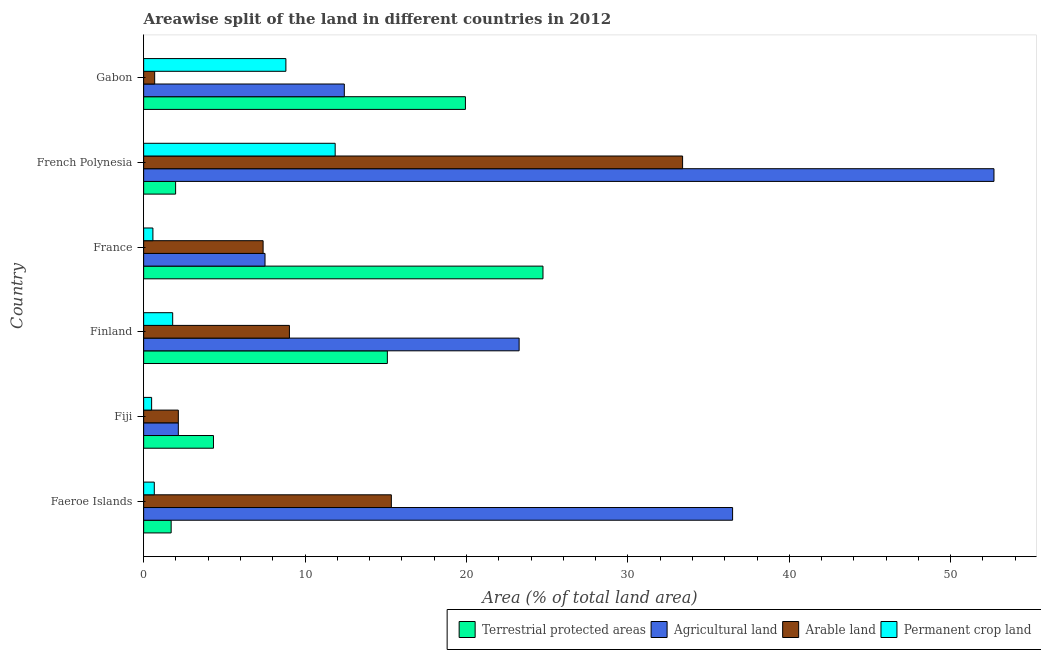Are the number of bars per tick equal to the number of legend labels?
Your response must be concise. Yes. Are the number of bars on each tick of the Y-axis equal?
Provide a short and direct response. Yes. How many bars are there on the 6th tick from the top?
Your response must be concise. 4. How many bars are there on the 6th tick from the bottom?
Make the answer very short. 4. What is the label of the 1st group of bars from the top?
Offer a terse response. Gabon. What is the percentage of area under arable land in Faeroe Islands?
Your answer should be very brief. 15.35. Across all countries, what is the maximum percentage of area under arable land?
Your response must be concise. 33.39. Across all countries, what is the minimum percentage of area under agricultural land?
Your response must be concise. 2.15. In which country was the percentage of area under permanent crop land maximum?
Your answer should be compact. French Polynesia. In which country was the percentage of area under arable land minimum?
Provide a short and direct response. Gabon. What is the total percentage of area under arable land in the graph?
Your answer should be very brief. 68. What is the difference between the percentage of area under agricultural land in French Polynesia and that in Gabon?
Make the answer very short. 40.25. What is the difference between the percentage of area under permanent crop land in Finland and the percentage of area under agricultural land in French Polynesia?
Ensure brevity in your answer.  -50.88. What is the average percentage of area under permanent crop land per country?
Offer a very short reply. 4.03. What is the difference between the percentage of area under agricultural land and percentage of area under permanent crop land in Faeroe Islands?
Provide a short and direct response. 35.83. What is the ratio of the percentage of land under terrestrial protection in Fiji to that in France?
Keep it short and to the point. 0.17. Is the difference between the percentage of area under arable land in Faeroe Islands and Finland greater than the difference between the percentage of land under terrestrial protection in Faeroe Islands and Finland?
Your response must be concise. Yes. What is the difference between the highest and the second highest percentage of area under agricultural land?
Provide a short and direct response. 16.19. What is the difference between the highest and the lowest percentage of area under agricultural land?
Your answer should be compact. 50.53. Is it the case that in every country, the sum of the percentage of area under agricultural land and percentage of area under permanent crop land is greater than the sum of percentage of land under terrestrial protection and percentage of area under arable land?
Offer a very short reply. No. What does the 2nd bar from the top in Finland represents?
Give a very brief answer. Arable land. What does the 3rd bar from the bottom in French Polynesia represents?
Your response must be concise. Arable land. Is it the case that in every country, the sum of the percentage of land under terrestrial protection and percentage of area under agricultural land is greater than the percentage of area under arable land?
Ensure brevity in your answer.  Yes. How many bars are there?
Offer a very short reply. 24. How many countries are there in the graph?
Your answer should be compact. 6. Are the values on the major ticks of X-axis written in scientific E-notation?
Your response must be concise. No. Does the graph contain any zero values?
Your response must be concise. No. Does the graph contain grids?
Keep it short and to the point. No. Where does the legend appear in the graph?
Your answer should be very brief. Bottom right. How many legend labels are there?
Ensure brevity in your answer.  4. How are the legend labels stacked?
Your response must be concise. Horizontal. What is the title of the graph?
Your answer should be very brief. Areawise split of the land in different countries in 2012. Does "Secondary" appear as one of the legend labels in the graph?
Your answer should be very brief. No. What is the label or title of the X-axis?
Make the answer very short. Area (% of total land area). What is the Area (% of total land area) of Terrestrial protected areas in Faeroe Islands?
Your answer should be compact. 1.7. What is the Area (% of total land area) in Agricultural land in Faeroe Islands?
Provide a short and direct response. 36.49. What is the Area (% of total land area) of Arable land in Faeroe Islands?
Keep it short and to the point. 15.35. What is the Area (% of total land area) in Permanent crop land in Faeroe Islands?
Offer a very short reply. 0.66. What is the Area (% of total land area) of Terrestrial protected areas in Fiji?
Your response must be concise. 4.33. What is the Area (% of total land area) in Agricultural land in Fiji?
Offer a terse response. 2.15. What is the Area (% of total land area) of Arable land in Fiji?
Offer a very short reply. 2.15. What is the Area (% of total land area) in Permanent crop land in Fiji?
Your answer should be compact. 0.49. What is the Area (% of total land area) of Terrestrial protected areas in Finland?
Make the answer very short. 15.1. What is the Area (% of total land area) of Agricultural land in Finland?
Your response must be concise. 23.26. What is the Area (% of total land area) of Arable land in Finland?
Provide a succinct answer. 9.03. What is the Area (% of total land area) of Permanent crop land in Finland?
Offer a terse response. 1.8. What is the Area (% of total land area) of Terrestrial protected areas in France?
Offer a very short reply. 24.74. What is the Area (% of total land area) of Agricultural land in France?
Provide a short and direct response. 7.52. What is the Area (% of total land area) in Arable land in France?
Your answer should be very brief. 7.4. What is the Area (% of total land area) of Permanent crop land in France?
Offer a terse response. 0.57. What is the Area (% of total land area) of Terrestrial protected areas in French Polynesia?
Your answer should be very brief. 1.98. What is the Area (% of total land area) in Agricultural land in French Polynesia?
Provide a short and direct response. 52.68. What is the Area (% of total land area) in Arable land in French Polynesia?
Offer a very short reply. 33.39. What is the Area (% of total land area) in Permanent crop land in French Polynesia?
Offer a terse response. 11.87. What is the Area (% of total land area) of Terrestrial protected areas in Gabon?
Offer a very short reply. 19.94. What is the Area (% of total land area) in Agricultural land in Gabon?
Ensure brevity in your answer.  12.43. What is the Area (% of total land area) of Arable land in Gabon?
Your response must be concise. 0.68. What is the Area (% of total land area) in Permanent crop land in Gabon?
Your answer should be compact. 8.81. Across all countries, what is the maximum Area (% of total land area) of Terrestrial protected areas?
Ensure brevity in your answer.  24.74. Across all countries, what is the maximum Area (% of total land area) in Agricultural land?
Provide a short and direct response. 52.68. Across all countries, what is the maximum Area (% of total land area) in Arable land?
Your answer should be compact. 33.39. Across all countries, what is the maximum Area (% of total land area) in Permanent crop land?
Your response must be concise. 11.87. Across all countries, what is the minimum Area (% of total land area) in Terrestrial protected areas?
Offer a very short reply. 1.7. Across all countries, what is the minimum Area (% of total land area) of Agricultural land?
Offer a terse response. 2.15. Across all countries, what is the minimum Area (% of total land area) in Arable land?
Provide a succinct answer. 0.68. Across all countries, what is the minimum Area (% of total land area) of Permanent crop land?
Ensure brevity in your answer.  0.49. What is the total Area (% of total land area) of Terrestrial protected areas in the graph?
Keep it short and to the point. 67.79. What is the total Area (% of total land area) of Agricultural land in the graph?
Your answer should be compact. 134.53. What is the total Area (% of total land area) of Arable land in the graph?
Your answer should be compact. 68. What is the total Area (% of total land area) in Permanent crop land in the graph?
Provide a succinct answer. 24.21. What is the difference between the Area (% of total land area) of Terrestrial protected areas in Faeroe Islands and that in Fiji?
Your answer should be compact. -2.62. What is the difference between the Area (% of total land area) of Agricultural land in Faeroe Islands and that in Fiji?
Your response must be concise. 34.34. What is the difference between the Area (% of total land area) of Arable land in Faeroe Islands and that in Fiji?
Offer a very short reply. 13.2. What is the difference between the Area (% of total land area) of Permanent crop land in Faeroe Islands and that in Fiji?
Make the answer very short. 0.17. What is the difference between the Area (% of total land area) of Terrestrial protected areas in Faeroe Islands and that in Finland?
Make the answer very short. -13.39. What is the difference between the Area (% of total land area) in Agricultural land in Faeroe Islands and that in Finland?
Your answer should be very brief. 13.23. What is the difference between the Area (% of total land area) of Arable land in Faeroe Islands and that in Finland?
Make the answer very short. 6.31. What is the difference between the Area (% of total land area) in Permanent crop land in Faeroe Islands and that in Finland?
Your answer should be very brief. -1.14. What is the difference between the Area (% of total land area) in Terrestrial protected areas in Faeroe Islands and that in France?
Keep it short and to the point. -23.04. What is the difference between the Area (% of total land area) of Agricultural land in Faeroe Islands and that in France?
Offer a terse response. 28.97. What is the difference between the Area (% of total land area) of Arable land in Faeroe Islands and that in France?
Keep it short and to the point. 7.95. What is the difference between the Area (% of total land area) in Permanent crop land in Faeroe Islands and that in France?
Ensure brevity in your answer.  0.09. What is the difference between the Area (% of total land area) of Terrestrial protected areas in Faeroe Islands and that in French Polynesia?
Offer a very short reply. -0.28. What is the difference between the Area (% of total land area) of Agricultural land in Faeroe Islands and that in French Polynesia?
Give a very brief answer. -16.19. What is the difference between the Area (% of total land area) in Arable land in Faeroe Islands and that in French Polynesia?
Ensure brevity in your answer.  -18.04. What is the difference between the Area (% of total land area) in Permanent crop land in Faeroe Islands and that in French Polynesia?
Keep it short and to the point. -11.21. What is the difference between the Area (% of total land area) of Terrestrial protected areas in Faeroe Islands and that in Gabon?
Provide a short and direct response. -18.23. What is the difference between the Area (% of total land area) of Agricultural land in Faeroe Islands and that in Gabon?
Offer a terse response. 24.06. What is the difference between the Area (% of total land area) in Arable land in Faeroe Islands and that in Gabon?
Provide a short and direct response. 14.66. What is the difference between the Area (% of total land area) of Permanent crop land in Faeroe Islands and that in Gabon?
Give a very brief answer. -8.15. What is the difference between the Area (% of total land area) of Terrestrial protected areas in Fiji and that in Finland?
Offer a terse response. -10.77. What is the difference between the Area (% of total land area) of Agricultural land in Fiji and that in Finland?
Offer a very short reply. -21.11. What is the difference between the Area (% of total land area) in Arable land in Fiji and that in Finland?
Provide a short and direct response. -6.88. What is the difference between the Area (% of total land area) of Permanent crop land in Fiji and that in Finland?
Provide a succinct answer. -1.3. What is the difference between the Area (% of total land area) of Terrestrial protected areas in Fiji and that in France?
Your answer should be compact. -20.41. What is the difference between the Area (% of total land area) of Agricultural land in Fiji and that in France?
Provide a short and direct response. -5.37. What is the difference between the Area (% of total land area) of Arable land in Fiji and that in France?
Keep it short and to the point. -5.25. What is the difference between the Area (% of total land area) in Permanent crop land in Fiji and that in France?
Provide a short and direct response. -0.08. What is the difference between the Area (% of total land area) of Terrestrial protected areas in Fiji and that in French Polynesia?
Give a very brief answer. 2.35. What is the difference between the Area (% of total land area) of Agricultural land in Fiji and that in French Polynesia?
Your answer should be very brief. -50.53. What is the difference between the Area (% of total land area) of Arable land in Fiji and that in French Polynesia?
Your answer should be very brief. -31.24. What is the difference between the Area (% of total land area) of Permanent crop land in Fiji and that in French Polynesia?
Your answer should be compact. -11.37. What is the difference between the Area (% of total land area) of Terrestrial protected areas in Fiji and that in Gabon?
Provide a short and direct response. -15.61. What is the difference between the Area (% of total land area) in Agricultural land in Fiji and that in Gabon?
Your answer should be compact. -10.28. What is the difference between the Area (% of total land area) in Arable land in Fiji and that in Gabon?
Offer a very short reply. 1.47. What is the difference between the Area (% of total land area) in Permanent crop land in Fiji and that in Gabon?
Give a very brief answer. -8.32. What is the difference between the Area (% of total land area) of Terrestrial protected areas in Finland and that in France?
Offer a very short reply. -9.64. What is the difference between the Area (% of total land area) of Agricultural land in Finland and that in France?
Keep it short and to the point. 15.74. What is the difference between the Area (% of total land area) of Arable land in Finland and that in France?
Your answer should be compact. 1.63. What is the difference between the Area (% of total land area) of Permanent crop land in Finland and that in France?
Make the answer very short. 1.23. What is the difference between the Area (% of total land area) of Terrestrial protected areas in Finland and that in French Polynesia?
Make the answer very short. 13.12. What is the difference between the Area (% of total land area) in Agricultural land in Finland and that in French Polynesia?
Your response must be concise. -29.42. What is the difference between the Area (% of total land area) of Arable land in Finland and that in French Polynesia?
Make the answer very short. -24.36. What is the difference between the Area (% of total land area) in Permanent crop land in Finland and that in French Polynesia?
Provide a succinct answer. -10.07. What is the difference between the Area (% of total land area) of Terrestrial protected areas in Finland and that in Gabon?
Give a very brief answer. -4.84. What is the difference between the Area (% of total land area) in Agricultural land in Finland and that in Gabon?
Your response must be concise. 10.83. What is the difference between the Area (% of total land area) of Arable land in Finland and that in Gabon?
Offer a very short reply. 8.35. What is the difference between the Area (% of total land area) in Permanent crop land in Finland and that in Gabon?
Ensure brevity in your answer.  -7.01. What is the difference between the Area (% of total land area) in Terrestrial protected areas in France and that in French Polynesia?
Offer a very short reply. 22.76. What is the difference between the Area (% of total land area) in Agricultural land in France and that in French Polynesia?
Keep it short and to the point. -45.16. What is the difference between the Area (% of total land area) of Arable land in France and that in French Polynesia?
Offer a terse response. -25.99. What is the difference between the Area (% of total land area) of Permanent crop land in France and that in French Polynesia?
Provide a short and direct response. -11.29. What is the difference between the Area (% of total land area) of Terrestrial protected areas in France and that in Gabon?
Your response must be concise. 4.81. What is the difference between the Area (% of total land area) of Agricultural land in France and that in Gabon?
Provide a succinct answer. -4.91. What is the difference between the Area (% of total land area) in Arable land in France and that in Gabon?
Your response must be concise. 6.72. What is the difference between the Area (% of total land area) of Permanent crop land in France and that in Gabon?
Make the answer very short. -8.24. What is the difference between the Area (% of total land area) of Terrestrial protected areas in French Polynesia and that in Gabon?
Your response must be concise. -17.96. What is the difference between the Area (% of total land area) in Agricultural land in French Polynesia and that in Gabon?
Offer a very short reply. 40.25. What is the difference between the Area (% of total land area) in Arable land in French Polynesia and that in Gabon?
Ensure brevity in your answer.  32.71. What is the difference between the Area (% of total land area) in Permanent crop land in French Polynesia and that in Gabon?
Ensure brevity in your answer.  3.05. What is the difference between the Area (% of total land area) in Terrestrial protected areas in Faeroe Islands and the Area (% of total land area) in Agricultural land in Fiji?
Ensure brevity in your answer.  -0.44. What is the difference between the Area (% of total land area) in Terrestrial protected areas in Faeroe Islands and the Area (% of total land area) in Arable land in Fiji?
Offer a very short reply. -0.44. What is the difference between the Area (% of total land area) of Terrestrial protected areas in Faeroe Islands and the Area (% of total land area) of Permanent crop land in Fiji?
Ensure brevity in your answer.  1.21. What is the difference between the Area (% of total land area) in Agricultural land in Faeroe Islands and the Area (% of total land area) in Arable land in Fiji?
Ensure brevity in your answer.  34.34. What is the difference between the Area (% of total land area) of Agricultural land in Faeroe Islands and the Area (% of total land area) of Permanent crop land in Fiji?
Your response must be concise. 35.99. What is the difference between the Area (% of total land area) in Arable land in Faeroe Islands and the Area (% of total land area) in Permanent crop land in Fiji?
Your answer should be very brief. 14.85. What is the difference between the Area (% of total land area) of Terrestrial protected areas in Faeroe Islands and the Area (% of total land area) of Agricultural land in Finland?
Provide a short and direct response. -21.56. What is the difference between the Area (% of total land area) of Terrestrial protected areas in Faeroe Islands and the Area (% of total land area) of Arable land in Finland?
Provide a short and direct response. -7.33. What is the difference between the Area (% of total land area) in Terrestrial protected areas in Faeroe Islands and the Area (% of total land area) in Permanent crop land in Finland?
Your answer should be compact. -0.09. What is the difference between the Area (% of total land area) in Agricultural land in Faeroe Islands and the Area (% of total land area) in Arable land in Finland?
Your answer should be very brief. 27.46. What is the difference between the Area (% of total land area) in Agricultural land in Faeroe Islands and the Area (% of total land area) in Permanent crop land in Finland?
Your answer should be compact. 34.69. What is the difference between the Area (% of total land area) in Arable land in Faeroe Islands and the Area (% of total land area) in Permanent crop land in Finland?
Provide a short and direct response. 13.55. What is the difference between the Area (% of total land area) in Terrestrial protected areas in Faeroe Islands and the Area (% of total land area) in Agricultural land in France?
Make the answer very short. -5.82. What is the difference between the Area (% of total land area) of Terrestrial protected areas in Faeroe Islands and the Area (% of total land area) of Arable land in France?
Offer a very short reply. -5.7. What is the difference between the Area (% of total land area) in Terrestrial protected areas in Faeroe Islands and the Area (% of total land area) in Permanent crop land in France?
Your answer should be compact. 1.13. What is the difference between the Area (% of total land area) of Agricultural land in Faeroe Islands and the Area (% of total land area) of Arable land in France?
Provide a succinct answer. 29.09. What is the difference between the Area (% of total land area) in Agricultural land in Faeroe Islands and the Area (% of total land area) in Permanent crop land in France?
Ensure brevity in your answer.  35.91. What is the difference between the Area (% of total land area) in Arable land in Faeroe Islands and the Area (% of total land area) in Permanent crop land in France?
Your answer should be compact. 14.77. What is the difference between the Area (% of total land area) in Terrestrial protected areas in Faeroe Islands and the Area (% of total land area) in Agricultural land in French Polynesia?
Your response must be concise. -50.98. What is the difference between the Area (% of total land area) of Terrestrial protected areas in Faeroe Islands and the Area (% of total land area) of Arable land in French Polynesia?
Offer a very short reply. -31.69. What is the difference between the Area (% of total land area) in Terrestrial protected areas in Faeroe Islands and the Area (% of total land area) in Permanent crop land in French Polynesia?
Ensure brevity in your answer.  -10.16. What is the difference between the Area (% of total land area) of Agricultural land in Faeroe Islands and the Area (% of total land area) of Arable land in French Polynesia?
Keep it short and to the point. 3.1. What is the difference between the Area (% of total land area) in Agricultural land in Faeroe Islands and the Area (% of total land area) in Permanent crop land in French Polynesia?
Your response must be concise. 24.62. What is the difference between the Area (% of total land area) in Arable land in Faeroe Islands and the Area (% of total land area) in Permanent crop land in French Polynesia?
Provide a succinct answer. 3.48. What is the difference between the Area (% of total land area) in Terrestrial protected areas in Faeroe Islands and the Area (% of total land area) in Agricultural land in Gabon?
Provide a short and direct response. -10.73. What is the difference between the Area (% of total land area) of Terrestrial protected areas in Faeroe Islands and the Area (% of total land area) of Arable land in Gabon?
Provide a short and direct response. 1.02. What is the difference between the Area (% of total land area) in Terrestrial protected areas in Faeroe Islands and the Area (% of total land area) in Permanent crop land in Gabon?
Give a very brief answer. -7.11. What is the difference between the Area (% of total land area) in Agricultural land in Faeroe Islands and the Area (% of total land area) in Arable land in Gabon?
Offer a very short reply. 35.8. What is the difference between the Area (% of total land area) of Agricultural land in Faeroe Islands and the Area (% of total land area) of Permanent crop land in Gabon?
Your answer should be compact. 27.68. What is the difference between the Area (% of total land area) of Arable land in Faeroe Islands and the Area (% of total land area) of Permanent crop land in Gabon?
Keep it short and to the point. 6.53. What is the difference between the Area (% of total land area) in Terrestrial protected areas in Fiji and the Area (% of total land area) in Agricultural land in Finland?
Provide a succinct answer. -18.94. What is the difference between the Area (% of total land area) in Terrestrial protected areas in Fiji and the Area (% of total land area) in Arable land in Finland?
Provide a succinct answer. -4.71. What is the difference between the Area (% of total land area) of Terrestrial protected areas in Fiji and the Area (% of total land area) of Permanent crop land in Finland?
Your answer should be compact. 2.53. What is the difference between the Area (% of total land area) in Agricultural land in Fiji and the Area (% of total land area) in Arable land in Finland?
Your response must be concise. -6.88. What is the difference between the Area (% of total land area) of Agricultural land in Fiji and the Area (% of total land area) of Permanent crop land in Finland?
Your response must be concise. 0.35. What is the difference between the Area (% of total land area) in Arable land in Fiji and the Area (% of total land area) in Permanent crop land in Finland?
Offer a very short reply. 0.35. What is the difference between the Area (% of total land area) of Terrestrial protected areas in Fiji and the Area (% of total land area) of Agricultural land in France?
Offer a terse response. -3.19. What is the difference between the Area (% of total land area) in Terrestrial protected areas in Fiji and the Area (% of total land area) in Arable land in France?
Provide a succinct answer. -3.08. What is the difference between the Area (% of total land area) in Terrestrial protected areas in Fiji and the Area (% of total land area) in Permanent crop land in France?
Offer a terse response. 3.75. What is the difference between the Area (% of total land area) of Agricultural land in Fiji and the Area (% of total land area) of Arable land in France?
Your answer should be very brief. -5.25. What is the difference between the Area (% of total land area) in Agricultural land in Fiji and the Area (% of total land area) in Permanent crop land in France?
Make the answer very short. 1.58. What is the difference between the Area (% of total land area) of Arable land in Fiji and the Area (% of total land area) of Permanent crop land in France?
Give a very brief answer. 1.58. What is the difference between the Area (% of total land area) of Terrestrial protected areas in Fiji and the Area (% of total land area) of Agricultural land in French Polynesia?
Make the answer very short. -48.36. What is the difference between the Area (% of total land area) of Terrestrial protected areas in Fiji and the Area (% of total land area) of Arable land in French Polynesia?
Your answer should be very brief. -29.06. What is the difference between the Area (% of total land area) in Terrestrial protected areas in Fiji and the Area (% of total land area) in Permanent crop land in French Polynesia?
Offer a very short reply. -7.54. What is the difference between the Area (% of total land area) of Agricultural land in Fiji and the Area (% of total land area) of Arable land in French Polynesia?
Provide a succinct answer. -31.24. What is the difference between the Area (% of total land area) in Agricultural land in Fiji and the Area (% of total land area) in Permanent crop land in French Polynesia?
Keep it short and to the point. -9.72. What is the difference between the Area (% of total land area) of Arable land in Fiji and the Area (% of total land area) of Permanent crop land in French Polynesia?
Your answer should be very brief. -9.72. What is the difference between the Area (% of total land area) of Terrestrial protected areas in Fiji and the Area (% of total land area) of Agricultural land in Gabon?
Your answer should be very brief. -8.11. What is the difference between the Area (% of total land area) of Terrestrial protected areas in Fiji and the Area (% of total land area) of Arable land in Gabon?
Offer a very short reply. 3.64. What is the difference between the Area (% of total land area) in Terrestrial protected areas in Fiji and the Area (% of total land area) in Permanent crop land in Gabon?
Make the answer very short. -4.49. What is the difference between the Area (% of total land area) of Agricultural land in Fiji and the Area (% of total land area) of Arable land in Gabon?
Your answer should be very brief. 1.47. What is the difference between the Area (% of total land area) in Agricultural land in Fiji and the Area (% of total land area) in Permanent crop land in Gabon?
Offer a terse response. -6.66. What is the difference between the Area (% of total land area) of Arable land in Fiji and the Area (% of total land area) of Permanent crop land in Gabon?
Ensure brevity in your answer.  -6.66. What is the difference between the Area (% of total land area) in Terrestrial protected areas in Finland and the Area (% of total land area) in Agricultural land in France?
Keep it short and to the point. 7.58. What is the difference between the Area (% of total land area) in Terrestrial protected areas in Finland and the Area (% of total land area) in Arable land in France?
Keep it short and to the point. 7.7. What is the difference between the Area (% of total land area) in Terrestrial protected areas in Finland and the Area (% of total land area) in Permanent crop land in France?
Provide a short and direct response. 14.53. What is the difference between the Area (% of total land area) in Agricultural land in Finland and the Area (% of total land area) in Arable land in France?
Offer a very short reply. 15.86. What is the difference between the Area (% of total land area) in Agricultural land in Finland and the Area (% of total land area) in Permanent crop land in France?
Offer a very short reply. 22.69. What is the difference between the Area (% of total land area) of Arable land in Finland and the Area (% of total land area) of Permanent crop land in France?
Provide a succinct answer. 8.46. What is the difference between the Area (% of total land area) in Terrestrial protected areas in Finland and the Area (% of total land area) in Agricultural land in French Polynesia?
Your response must be concise. -37.58. What is the difference between the Area (% of total land area) in Terrestrial protected areas in Finland and the Area (% of total land area) in Arable land in French Polynesia?
Your response must be concise. -18.29. What is the difference between the Area (% of total land area) of Terrestrial protected areas in Finland and the Area (% of total land area) of Permanent crop land in French Polynesia?
Your response must be concise. 3.23. What is the difference between the Area (% of total land area) in Agricultural land in Finland and the Area (% of total land area) in Arable land in French Polynesia?
Make the answer very short. -10.13. What is the difference between the Area (% of total land area) in Agricultural land in Finland and the Area (% of total land area) in Permanent crop land in French Polynesia?
Provide a short and direct response. 11.4. What is the difference between the Area (% of total land area) of Arable land in Finland and the Area (% of total land area) of Permanent crop land in French Polynesia?
Your answer should be compact. -2.83. What is the difference between the Area (% of total land area) in Terrestrial protected areas in Finland and the Area (% of total land area) in Agricultural land in Gabon?
Keep it short and to the point. 2.67. What is the difference between the Area (% of total land area) of Terrestrial protected areas in Finland and the Area (% of total land area) of Arable land in Gabon?
Your answer should be very brief. 14.42. What is the difference between the Area (% of total land area) of Terrestrial protected areas in Finland and the Area (% of total land area) of Permanent crop land in Gabon?
Provide a succinct answer. 6.29. What is the difference between the Area (% of total land area) in Agricultural land in Finland and the Area (% of total land area) in Arable land in Gabon?
Offer a very short reply. 22.58. What is the difference between the Area (% of total land area) in Agricultural land in Finland and the Area (% of total land area) in Permanent crop land in Gabon?
Your answer should be very brief. 14.45. What is the difference between the Area (% of total land area) of Arable land in Finland and the Area (% of total land area) of Permanent crop land in Gabon?
Give a very brief answer. 0.22. What is the difference between the Area (% of total land area) of Terrestrial protected areas in France and the Area (% of total land area) of Agricultural land in French Polynesia?
Keep it short and to the point. -27.94. What is the difference between the Area (% of total land area) of Terrestrial protected areas in France and the Area (% of total land area) of Arable land in French Polynesia?
Give a very brief answer. -8.65. What is the difference between the Area (% of total land area) of Terrestrial protected areas in France and the Area (% of total land area) of Permanent crop land in French Polynesia?
Keep it short and to the point. 12.87. What is the difference between the Area (% of total land area) in Agricultural land in France and the Area (% of total land area) in Arable land in French Polynesia?
Offer a terse response. -25.87. What is the difference between the Area (% of total land area) of Agricultural land in France and the Area (% of total land area) of Permanent crop land in French Polynesia?
Offer a terse response. -4.35. What is the difference between the Area (% of total land area) of Arable land in France and the Area (% of total land area) of Permanent crop land in French Polynesia?
Ensure brevity in your answer.  -4.46. What is the difference between the Area (% of total land area) of Terrestrial protected areas in France and the Area (% of total land area) of Agricultural land in Gabon?
Ensure brevity in your answer.  12.31. What is the difference between the Area (% of total land area) of Terrestrial protected areas in France and the Area (% of total land area) of Arable land in Gabon?
Provide a short and direct response. 24.06. What is the difference between the Area (% of total land area) in Terrestrial protected areas in France and the Area (% of total land area) in Permanent crop land in Gabon?
Your answer should be very brief. 15.93. What is the difference between the Area (% of total land area) of Agricultural land in France and the Area (% of total land area) of Arable land in Gabon?
Make the answer very short. 6.84. What is the difference between the Area (% of total land area) of Agricultural land in France and the Area (% of total land area) of Permanent crop land in Gabon?
Keep it short and to the point. -1.29. What is the difference between the Area (% of total land area) in Arable land in France and the Area (% of total land area) in Permanent crop land in Gabon?
Give a very brief answer. -1.41. What is the difference between the Area (% of total land area) in Terrestrial protected areas in French Polynesia and the Area (% of total land area) in Agricultural land in Gabon?
Provide a succinct answer. -10.45. What is the difference between the Area (% of total land area) in Terrestrial protected areas in French Polynesia and the Area (% of total land area) in Arable land in Gabon?
Provide a short and direct response. 1.3. What is the difference between the Area (% of total land area) in Terrestrial protected areas in French Polynesia and the Area (% of total land area) in Permanent crop land in Gabon?
Your answer should be compact. -6.83. What is the difference between the Area (% of total land area) of Agricultural land in French Polynesia and the Area (% of total land area) of Arable land in Gabon?
Keep it short and to the point. 52. What is the difference between the Area (% of total land area) in Agricultural land in French Polynesia and the Area (% of total land area) in Permanent crop land in Gabon?
Keep it short and to the point. 43.87. What is the difference between the Area (% of total land area) of Arable land in French Polynesia and the Area (% of total land area) of Permanent crop land in Gabon?
Offer a terse response. 24.58. What is the average Area (% of total land area) of Terrestrial protected areas per country?
Your answer should be compact. 11.3. What is the average Area (% of total land area) in Agricultural land per country?
Offer a terse response. 22.42. What is the average Area (% of total land area) of Arable land per country?
Your answer should be compact. 11.33. What is the average Area (% of total land area) in Permanent crop land per country?
Ensure brevity in your answer.  4.03. What is the difference between the Area (% of total land area) of Terrestrial protected areas and Area (% of total land area) of Agricultural land in Faeroe Islands?
Your answer should be very brief. -34.78. What is the difference between the Area (% of total land area) of Terrestrial protected areas and Area (% of total land area) of Arable land in Faeroe Islands?
Provide a succinct answer. -13.64. What is the difference between the Area (% of total land area) in Terrestrial protected areas and Area (% of total land area) in Permanent crop land in Faeroe Islands?
Your answer should be very brief. 1.04. What is the difference between the Area (% of total land area) in Agricultural land and Area (% of total land area) in Arable land in Faeroe Islands?
Offer a very short reply. 21.14. What is the difference between the Area (% of total land area) of Agricultural land and Area (% of total land area) of Permanent crop land in Faeroe Islands?
Your answer should be compact. 35.83. What is the difference between the Area (% of total land area) of Arable land and Area (% of total land area) of Permanent crop land in Faeroe Islands?
Keep it short and to the point. 14.69. What is the difference between the Area (% of total land area) in Terrestrial protected areas and Area (% of total land area) in Agricultural land in Fiji?
Make the answer very short. 2.18. What is the difference between the Area (% of total land area) in Terrestrial protected areas and Area (% of total land area) in Arable land in Fiji?
Provide a succinct answer. 2.18. What is the difference between the Area (% of total land area) in Terrestrial protected areas and Area (% of total land area) in Permanent crop land in Fiji?
Make the answer very short. 3.83. What is the difference between the Area (% of total land area) in Agricultural land and Area (% of total land area) in Permanent crop land in Fiji?
Give a very brief answer. 1.65. What is the difference between the Area (% of total land area) in Arable land and Area (% of total land area) in Permanent crop land in Fiji?
Keep it short and to the point. 1.65. What is the difference between the Area (% of total land area) in Terrestrial protected areas and Area (% of total land area) in Agricultural land in Finland?
Provide a short and direct response. -8.16. What is the difference between the Area (% of total land area) in Terrestrial protected areas and Area (% of total land area) in Arable land in Finland?
Ensure brevity in your answer.  6.07. What is the difference between the Area (% of total land area) of Terrestrial protected areas and Area (% of total land area) of Permanent crop land in Finland?
Make the answer very short. 13.3. What is the difference between the Area (% of total land area) in Agricultural land and Area (% of total land area) in Arable land in Finland?
Your response must be concise. 14.23. What is the difference between the Area (% of total land area) in Agricultural land and Area (% of total land area) in Permanent crop land in Finland?
Your answer should be very brief. 21.46. What is the difference between the Area (% of total land area) in Arable land and Area (% of total land area) in Permanent crop land in Finland?
Make the answer very short. 7.23. What is the difference between the Area (% of total land area) in Terrestrial protected areas and Area (% of total land area) in Agricultural land in France?
Your answer should be very brief. 17.22. What is the difference between the Area (% of total land area) in Terrestrial protected areas and Area (% of total land area) in Arable land in France?
Your response must be concise. 17.34. What is the difference between the Area (% of total land area) of Terrestrial protected areas and Area (% of total land area) of Permanent crop land in France?
Offer a very short reply. 24.17. What is the difference between the Area (% of total land area) in Agricultural land and Area (% of total land area) in Arable land in France?
Keep it short and to the point. 0.12. What is the difference between the Area (% of total land area) of Agricultural land and Area (% of total land area) of Permanent crop land in France?
Keep it short and to the point. 6.95. What is the difference between the Area (% of total land area) in Arable land and Area (% of total land area) in Permanent crop land in France?
Make the answer very short. 6.83. What is the difference between the Area (% of total land area) of Terrestrial protected areas and Area (% of total land area) of Agricultural land in French Polynesia?
Ensure brevity in your answer.  -50.7. What is the difference between the Area (% of total land area) in Terrestrial protected areas and Area (% of total land area) in Arable land in French Polynesia?
Ensure brevity in your answer.  -31.41. What is the difference between the Area (% of total land area) in Terrestrial protected areas and Area (% of total land area) in Permanent crop land in French Polynesia?
Give a very brief answer. -9.89. What is the difference between the Area (% of total land area) of Agricultural land and Area (% of total land area) of Arable land in French Polynesia?
Offer a very short reply. 19.29. What is the difference between the Area (% of total land area) in Agricultural land and Area (% of total land area) in Permanent crop land in French Polynesia?
Make the answer very short. 40.82. What is the difference between the Area (% of total land area) in Arable land and Area (% of total land area) in Permanent crop land in French Polynesia?
Give a very brief answer. 21.52. What is the difference between the Area (% of total land area) of Terrestrial protected areas and Area (% of total land area) of Agricultural land in Gabon?
Make the answer very short. 7.5. What is the difference between the Area (% of total land area) in Terrestrial protected areas and Area (% of total land area) in Arable land in Gabon?
Your answer should be compact. 19.25. What is the difference between the Area (% of total land area) in Terrestrial protected areas and Area (% of total land area) in Permanent crop land in Gabon?
Your answer should be very brief. 11.12. What is the difference between the Area (% of total land area) in Agricultural land and Area (% of total land area) in Arable land in Gabon?
Keep it short and to the point. 11.75. What is the difference between the Area (% of total land area) in Agricultural land and Area (% of total land area) in Permanent crop land in Gabon?
Your response must be concise. 3.62. What is the difference between the Area (% of total land area) in Arable land and Area (% of total land area) in Permanent crop land in Gabon?
Provide a short and direct response. -8.13. What is the ratio of the Area (% of total land area) in Terrestrial protected areas in Faeroe Islands to that in Fiji?
Ensure brevity in your answer.  0.39. What is the ratio of the Area (% of total land area) of Agricultural land in Faeroe Islands to that in Fiji?
Ensure brevity in your answer.  16.98. What is the ratio of the Area (% of total land area) of Arable land in Faeroe Islands to that in Fiji?
Offer a very short reply. 7.14. What is the ratio of the Area (% of total land area) in Permanent crop land in Faeroe Islands to that in Fiji?
Provide a succinct answer. 1.34. What is the ratio of the Area (% of total land area) of Terrestrial protected areas in Faeroe Islands to that in Finland?
Offer a very short reply. 0.11. What is the ratio of the Area (% of total land area) of Agricultural land in Faeroe Islands to that in Finland?
Provide a succinct answer. 1.57. What is the ratio of the Area (% of total land area) in Arable land in Faeroe Islands to that in Finland?
Offer a terse response. 1.7. What is the ratio of the Area (% of total land area) in Permanent crop land in Faeroe Islands to that in Finland?
Give a very brief answer. 0.37. What is the ratio of the Area (% of total land area) in Terrestrial protected areas in Faeroe Islands to that in France?
Give a very brief answer. 0.07. What is the ratio of the Area (% of total land area) in Agricultural land in Faeroe Islands to that in France?
Make the answer very short. 4.85. What is the ratio of the Area (% of total land area) in Arable land in Faeroe Islands to that in France?
Your answer should be very brief. 2.07. What is the ratio of the Area (% of total land area) of Permanent crop land in Faeroe Islands to that in France?
Give a very brief answer. 1.15. What is the ratio of the Area (% of total land area) of Terrestrial protected areas in Faeroe Islands to that in French Polynesia?
Provide a short and direct response. 0.86. What is the ratio of the Area (% of total land area) in Agricultural land in Faeroe Islands to that in French Polynesia?
Your answer should be very brief. 0.69. What is the ratio of the Area (% of total land area) in Arable land in Faeroe Islands to that in French Polynesia?
Provide a short and direct response. 0.46. What is the ratio of the Area (% of total land area) in Permanent crop land in Faeroe Islands to that in French Polynesia?
Your response must be concise. 0.06. What is the ratio of the Area (% of total land area) in Terrestrial protected areas in Faeroe Islands to that in Gabon?
Offer a terse response. 0.09. What is the ratio of the Area (% of total land area) of Agricultural land in Faeroe Islands to that in Gabon?
Ensure brevity in your answer.  2.94. What is the ratio of the Area (% of total land area) in Arable land in Faeroe Islands to that in Gabon?
Your response must be concise. 22.47. What is the ratio of the Area (% of total land area) in Permanent crop land in Faeroe Islands to that in Gabon?
Offer a terse response. 0.07. What is the ratio of the Area (% of total land area) in Terrestrial protected areas in Fiji to that in Finland?
Provide a succinct answer. 0.29. What is the ratio of the Area (% of total land area) of Agricultural land in Fiji to that in Finland?
Give a very brief answer. 0.09. What is the ratio of the Area (% of total land area) in Arable land in Fiji to that in Finland?
Provide a short and direct response. 0.24. What is the ratio of the Area (% of total land area) in Permanent crop land in Fiji to that in Finland?
Provide a succinct answer. 0.27. What is the ratio of the Area (% of total land area) in Terrestrial protected areas in Fiji to that in France?
Your response must be concise. 0.17. What is the ratio of the Area (% of total land area) of Agricultural land in Fiji to that in France?
Provide a succinct answer. 0.29. What is the ratio of the Area (% of total land area) in Arable land in Fiji to that in France?
Provide a succinct answer. 0.29. What is the ratio of the Area (% of total land area) in Permanent crop land in Fiji to that in France?
Offer a very short reply. 0.86. What is the ratio of the Area (% of total land area) of Terrestrial protected areas in Fiji to that in French Polynesia?
Provide a short and direct response. 2.18. What is the ratio of the Area (% of total land area) in Agricultural land in Fiji to that in French Polynesia?
Provide a short and direct response. 0.04. What is the ratio of the Area (% of total land area) of Arable land in Fiji to that in French Polynesia?
Offer a very short reply. 0.06. What is the ratio of the Area (% of total land area) of Permanent crop land in Fiji to that in French Polynesia?
Give a very brief answer. 0.04. What is the ratio of the Area (% of total land area) of Terrestrial protected areas in Fiji to that in Gabon?
Provide a succinct answer. 0.22. What is the ratio of the Area (% of total land area) of Agricultural land in Fiji to that in Gabon?
Make the answer very short. 0.17. What is the ratio of the Area (% of total land area) in Arable land in Fiji to that in Gabon?
Your answer should be compact. 3.15. What is the ratio of the Area (% of total land area) of Permanent crop land in Fiji to that in Gabon?
Keep it short and to the point. 0.06. What is the ratio of the Area (% of total land area) in Terrestrial protected areas in Finland to that in France?
Ensure brevity in your answer.  0.61. What is the ratio of the Area (% of total land area) in Agricultural land in Finland to that in France?
Your response must be concise. 3.09. What is the ratio of the Area (% of total land area) in Arable land in Finland to that in France?
Offer a very short reply. 1.22. What is the ratio of the Area (% of total land area) of Permanent crop land in Finland to that in France?
Your answer should be very brief. 3.13. What is the ratio of the Area (% of total land area) of Terrestrial protected areas in Finland to that in French Polynesia?
Keep it short and to the point. 7.63. What is the ratio of the Area (% of total land area) in Agricultural land in Finland to that in French Polynesia?
Give a very brief answer. 0.44. What is the ratio of the Area (% of total land area) of Arable land in Finland to that in French Polynesia?
Keep it short and to the point. 0.27. What is the ratio of the Area (% of total land area) of Permanent crop land in Finland to that in French Polynesia?
Provide a short and direct response. 0.15. What is the ratio of the Area (% of total land area) of Terrestrial protected areas in Finland to that in Gabon?
Your answer should be compact. 0.76. What is the ratio of the Area (% of total land area) in Agricultural land in Finland to that in Gabon?
Offer a terse response. 1.87. What is the ratio of the Area (% of total land area) in Arable land in Finland to that in Gabon?
Offer a terse response. 13.22. What is the ratio of the Area (% of total land area) in Permanent crop land in Finland to that in Gabon?
Your response must be concise. 0.2. What is the ratio of the Area (% of total land area) in Terrestrial protected areas in France to that in French Polynesia?
Offer a terse response. 12.5. What is the ratio of the Area (% of total land area) in Agricultural land in France to that in French Polynesia?
Provide a succinct answer. 0.14. What is the ratio of the Area (% of total land area) of Arable land in France to that in French Polynesia?
Offer a terse response. 0.22. What is the ratio of the Area (% of total land area) of Permanent crop land in France to that in French Polynesia?
Your answer should be very brief. 0.05. What is the ratio of the Area (% of total land area) of Terrestrial protected areas in France to that in Gabon?
Give a very brief answer. 1.24. What is the ratio of the Area (% of total land area) in Agricultural land in France to that in Gabon?
Make the answer very short. 0.6. What is the ratio of the Area (% of total land area) of Arable land in France to that in Gabon?
Offer a very short reply. 10.84. What is the ratio of the Area (% of total land area) of Permanent crop land in France to that in Gabon?
Offer a terse response. 0.07. What is the ratio of the Area (% of total land area) of Terrestrial protected areas in French Polynesia to that in Gabon?
Keep it short and to the point. 0.1. What is the ratio of the Area (% of total land area) in Agricultural land in French Polynesia to that in Gabon?
Your answer should be compact. 4.24. What is the ratio of the Area (% of total land area) in Arable land in French Polynesia to that in Gabon?
Your answer should be very brief. 48.88. What is the ratio of the Area (% of total land area) of Permanent crop land in French Polynesia to that in Gabon?
Provide a short and direct response. 1.35. What is the difference between the highest and the second highest Area (% of total land area) of Terrestrial protected areas?
Ensure brevity in your answer.  4.81. What is the difference between the highest and the second highest Area (% of total land area) in Agricultural land?
Offer a terse response. 16.19. What is the difference between the highest and the second highest Area (% of total land area) in Arable land?
Offer a very short reply. 18.04. What is the difference between the highest and the second highest Area (% of total land area) of Permanent crop land?
Ensure brevity in your answer.  3.05. What is the difference between the highest and the lowest Area (% of total land area) in Terrestrial protected areas?
Give a very brief answer. 23.04. What is the difference between the highest and the lowest Area (% of total land area) in Agricultural land?
Offer a terse response. 50.53. What is the difference between the highest and the lowest Area (% of total land area) in Arable land?
Provide a short and direct response. 32.71. What is the difference between the highest and the lowest Area (% of total land area) of Permanent crop land?
Ensure brevity in your answer.  11.37. 